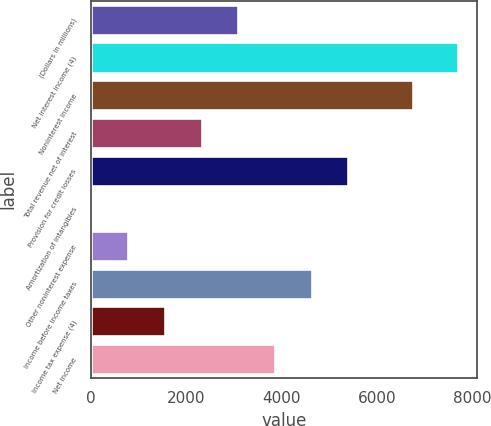Convert chart to OTSL. <chart><loc_0><loc_0><loc_500><loc_500><bar_chart><fcel>(Dollars in millions)<fcel>Net interest income (4)<fcel>Noninterest income<fcel>Total revenue net of interest<fcel>Provision for credit losses<fcel>Amortization of intangibles<fcel>Other noninterest expense<fcel>Income before income taxes<fcel>Income tax expense (4)<fcel>Net income<nl><fcel>3087.6<fcel>7701<fcel>6747<fcel>2318.7<fcel>5394.3<fcel>12<fcel>780.9<fcel>4625.4<fcel>1549.8<fcel>3856.5<nl></chart> 